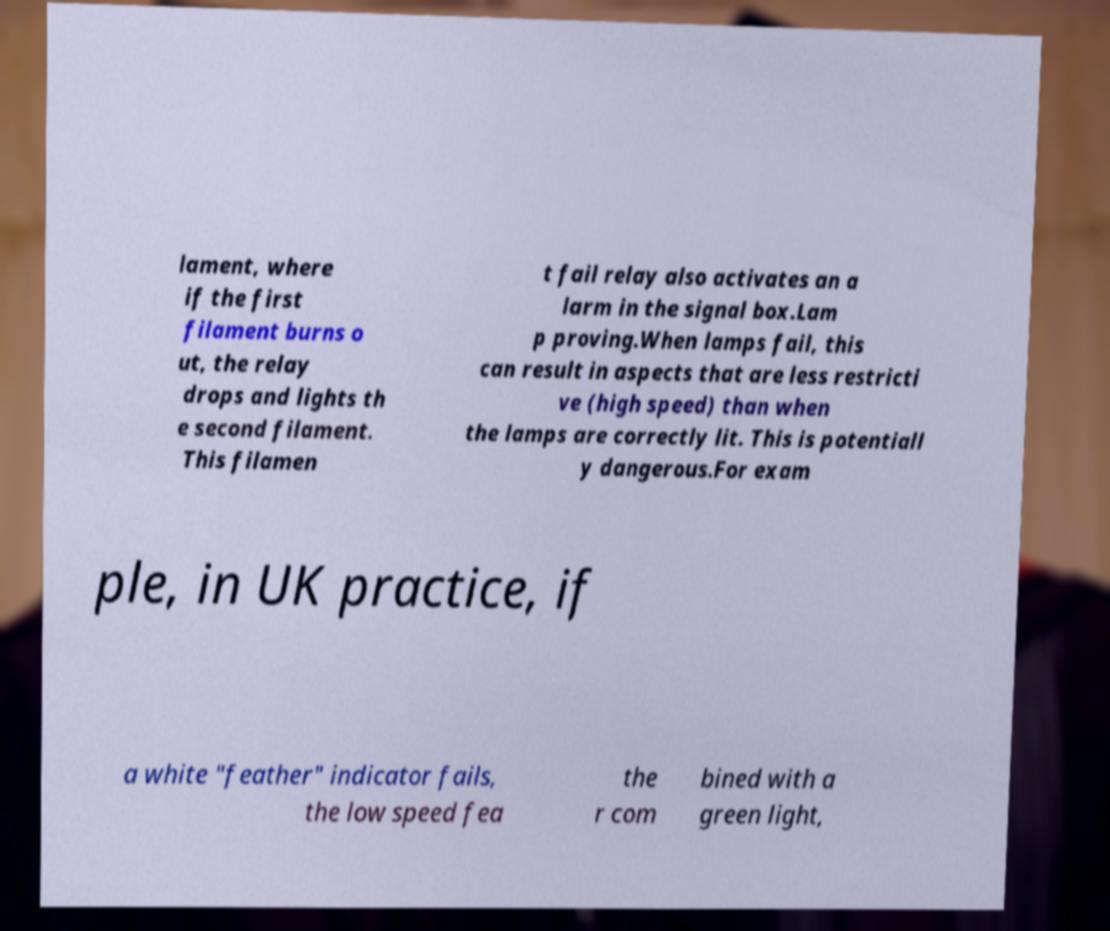Could you extract and type out the text from this image? lament, where if the first filament burns o ut, the relay drops and lights th e second filament. This filamen t fail relay also activates an a larm in the signal box.Lam p proving.When lamps fail, this can result in aspects that are less restricti ve (high speed) than when the lamps are correctly lit. This is potentiall y dangerous.For exam ple, in UK practice, if a white "feather" indicator fails, the low speed fea the r com bined with a green light, 